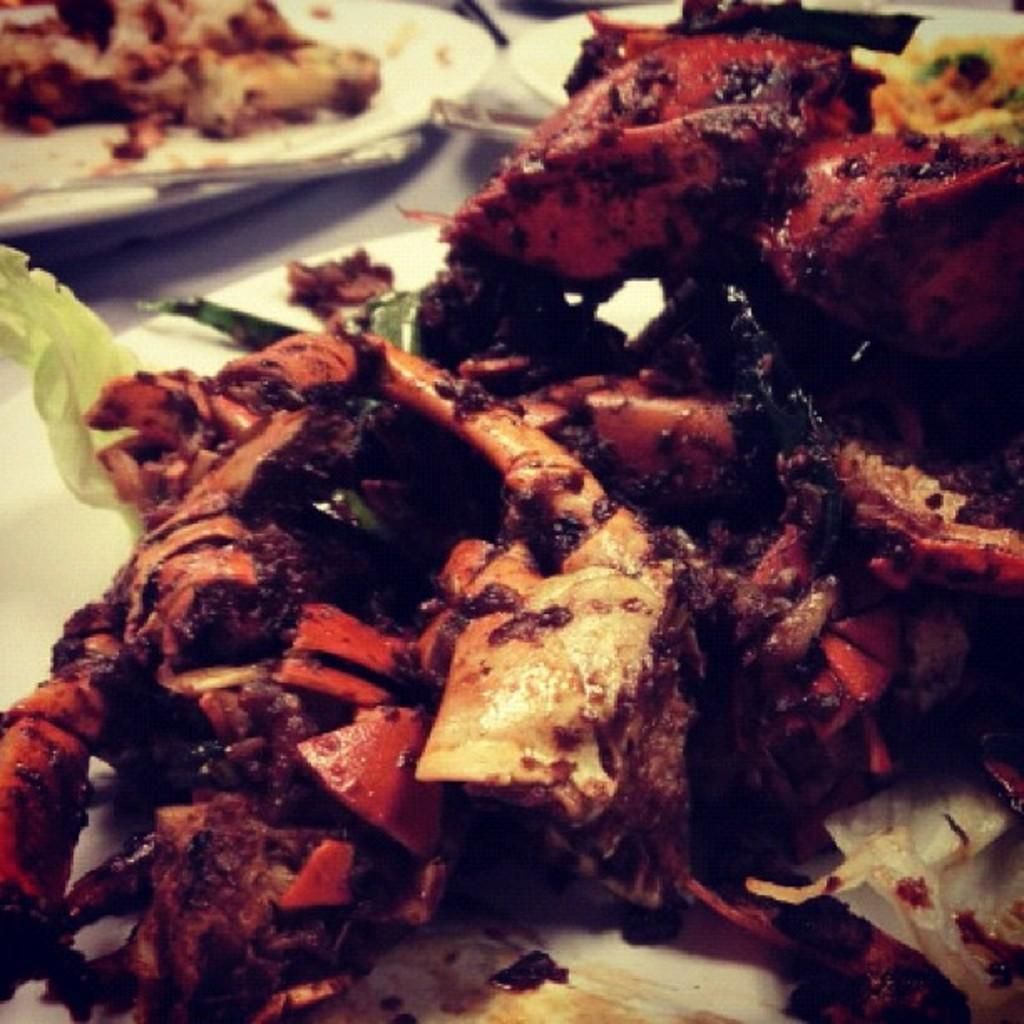What is the main food item visible on a plate in the image? There is a food item on a plate in the image, but the specific type of food cannot be determined from the provided facts. What can be seen in the background of the image? There are additional plates with food in the background of the image, along with spoons on the plates. What is the color of the surface the plates and spoons are placed on? The surface the plates and spoons are placed on is white in color. Reasoning: Let' Let's think step by step in order to produce the conversation. We start by identifying the main subject in the image, which is the food item on a plate. Then, we expand the conversation to include other plates and spoons visible in the background. We also mention the color of the surface the plates and spoons are placed on. Each question is designed to elicit a specific detail about the image that is known from the provided facts. Absurd Question/Answer: What type of dinosaurs can be seen playing with oranges in the image? There are no dinosaurs or oranges present in the image. 